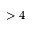Convert formula to latex. <formula><loc_0><loc_0><loc_500><loc_500>> 4</formula> 